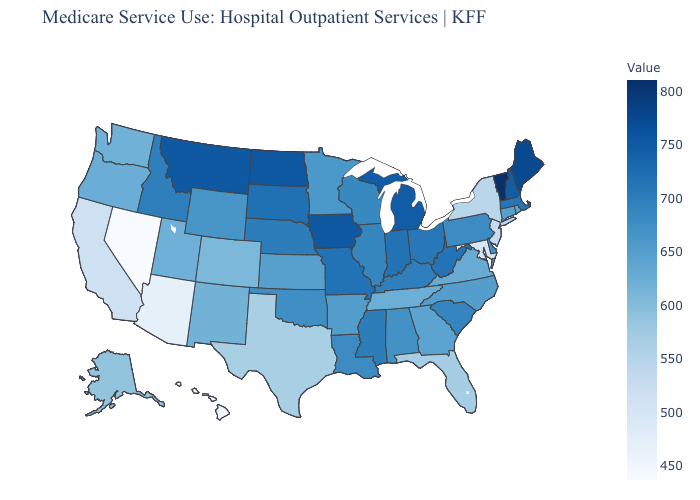Which states have the highest value in the USA?
Answer briefly. Vermont. Is the legend a continuous bar?
Be succinct. Yes. Among the states that border Louisiana , does Texas have the lowest value?
Give a very brief answer. Yes. 